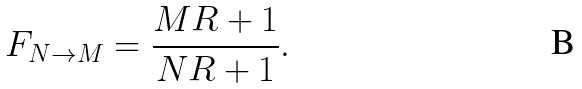Convert formula to latex. <formula><loc_0><loc_0><loc_500><loc_500>F _ { N \to M } = \frac { M R + 1 } { N R + 1 } .</formula> 